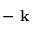Convert formula to latex. <formula><loc_0><loc_0><loc_500><loc_500>- k</formula> 